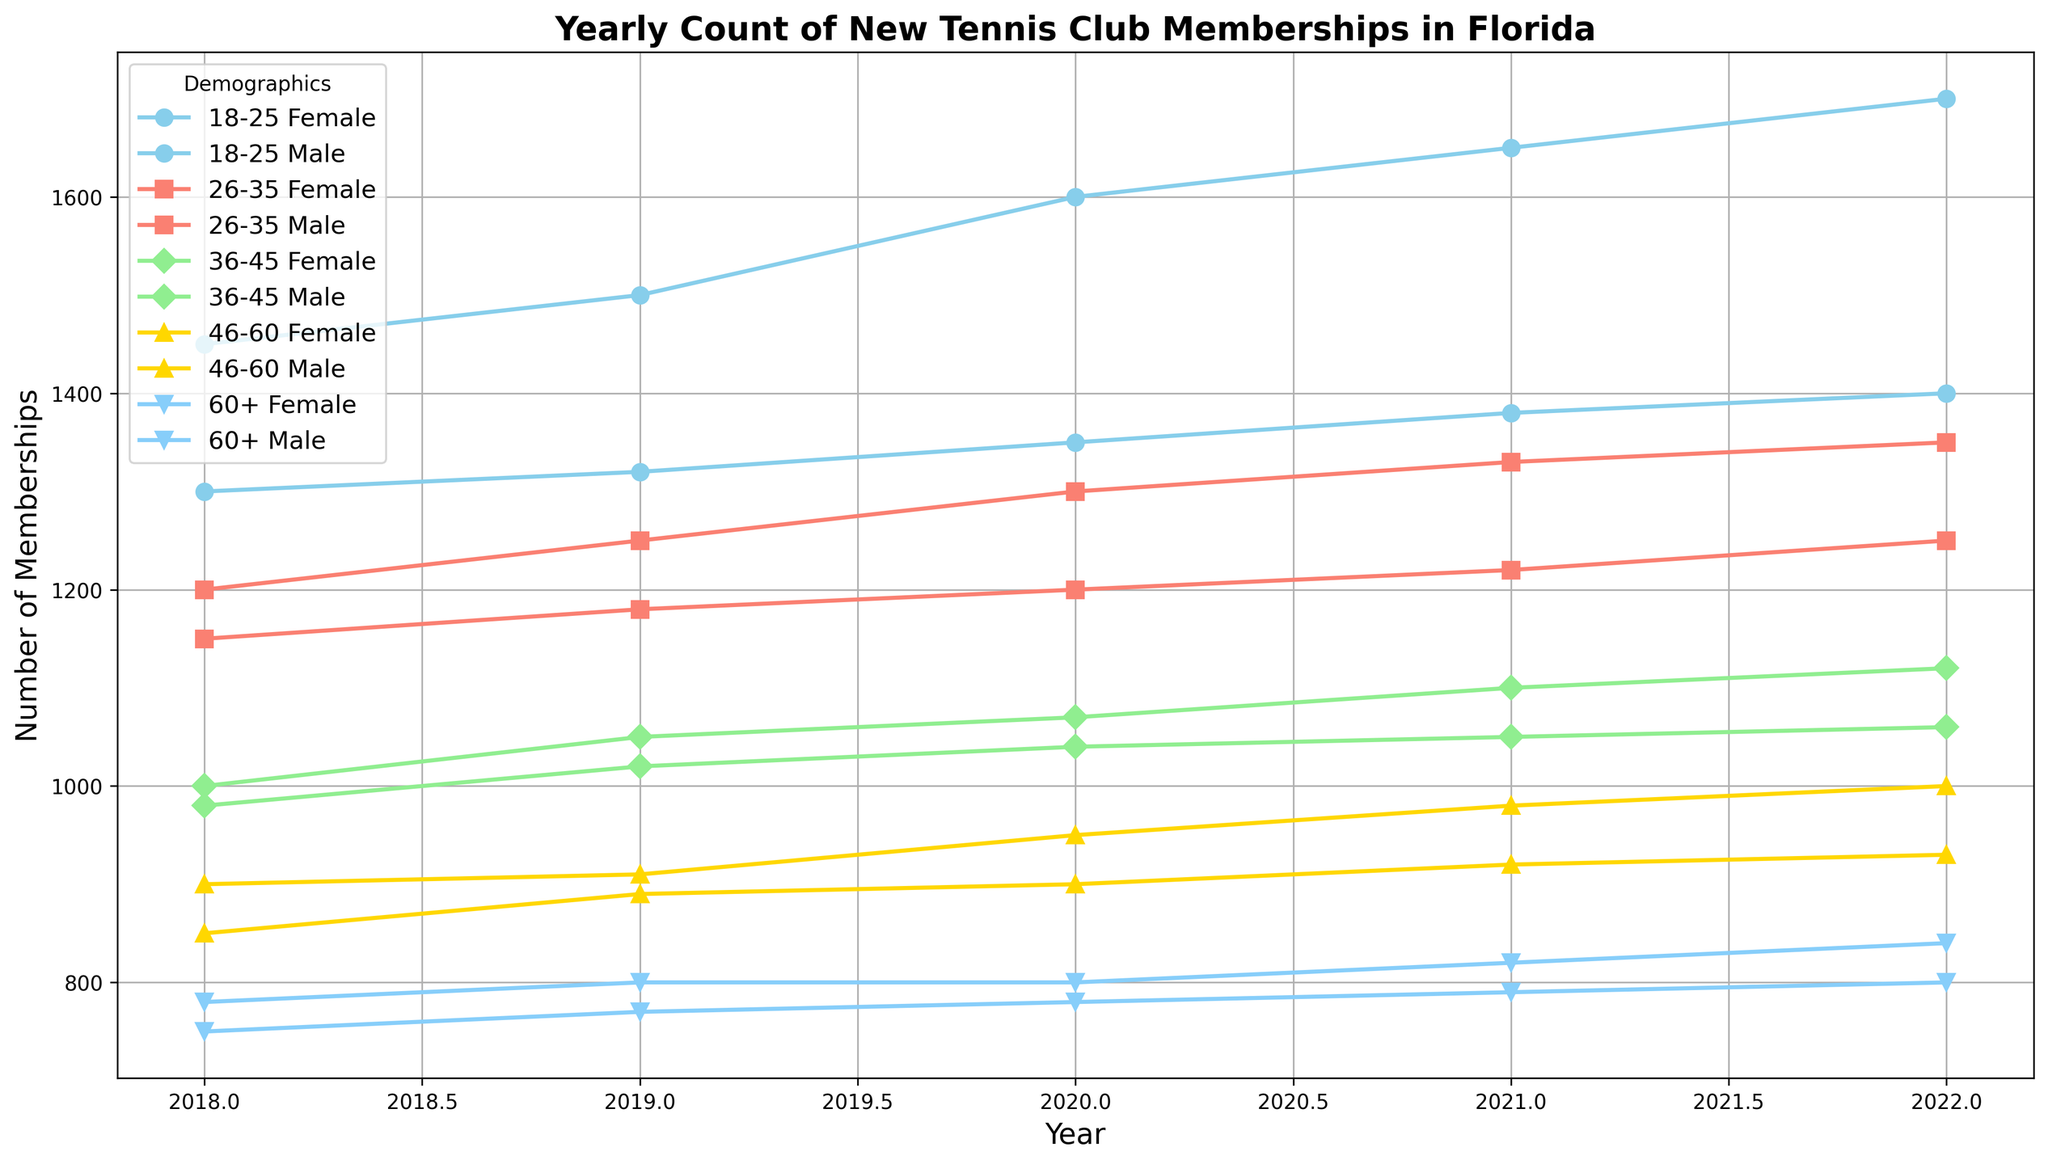Which age group had the highest increase in memberships from 2018 to 2022 for females? To identify the highest increase in memberships, compare the membership counts for each age group for females from 2018 to 2022. The calculations are as follows: 18-25: 1700 - 1450 = 250, 26-35: 1350 - 1200 = 150, 36-45: 1120 - 1000 = 120, 46-60: 930 - 850 = 80, 60+: 800 - 750 = 50. Thus, the highest increase is in the 18-25 age group.
Answer: 18-25 By how much did the male memberships in the 36-45 age group change from 2018 to 2022? Find the values for male memberships in the 36-45 age group for 2018 and 2022, then calculate the difference: 1060 - 980 = 80. Therefore, the change is an increase of 80.
Answer: 80 Which group had a higher number of memberships in 2021: Females aged 46-60 or Males aged 18-25? Check the membership counts for Females aged 46-60 in 2021, which is 920, and for Males aged 18-25 in 2021, which is 1380. Compare the two numbers: 920 < 1380. Thus, Males aged 18-25 had a higher number of memberships.
Answer: Males aged 18-25 What is the average number of memberships for Males in the 60+ age group over the years? To find the average, add the memberships for each year and divide by the number of years: (780 + 800 + 800 + 820 + 840) / 5 = 804. So, the average number of memberships is 804.
Answer: 804 Which gender had more memberships in the 26-35 age group in 2020? Compare memberships for 2020 in the 26-35 age group for both genders: Female (1300) and Male (1200). Since 1300 > 1200, females had more memberships.
Answer: Female What was the membership trend for males aged 18-25 from 2018 to 2022? Check the yearly memberships for males aged 18-25: 2018 (1300), 2019 (1320), 2020 (1350), 2021 (1380), 2022 (1400). Notice the pattern of continuous increase over the years. Therefore, the trend is upward.
Answer: Upward Calculate the total number of memberships in 2019 for all age groups and genders combined. Sum the membership numbers for all age groups and genders for the year 2019. Total = 1500 + 1320 + 1250 + 1180 + 1050 + 1020 + 890 + 910 + 770 + 800 = 11690. Thus, the total number of memberships is 11690.
Answer: 11690 What is the color representing the 46-60 age group's data in the plot? Identify the color associated with the data lines for the 46-60 age group, which is described in the data creation process. The color is gold.
Answer: Gold 